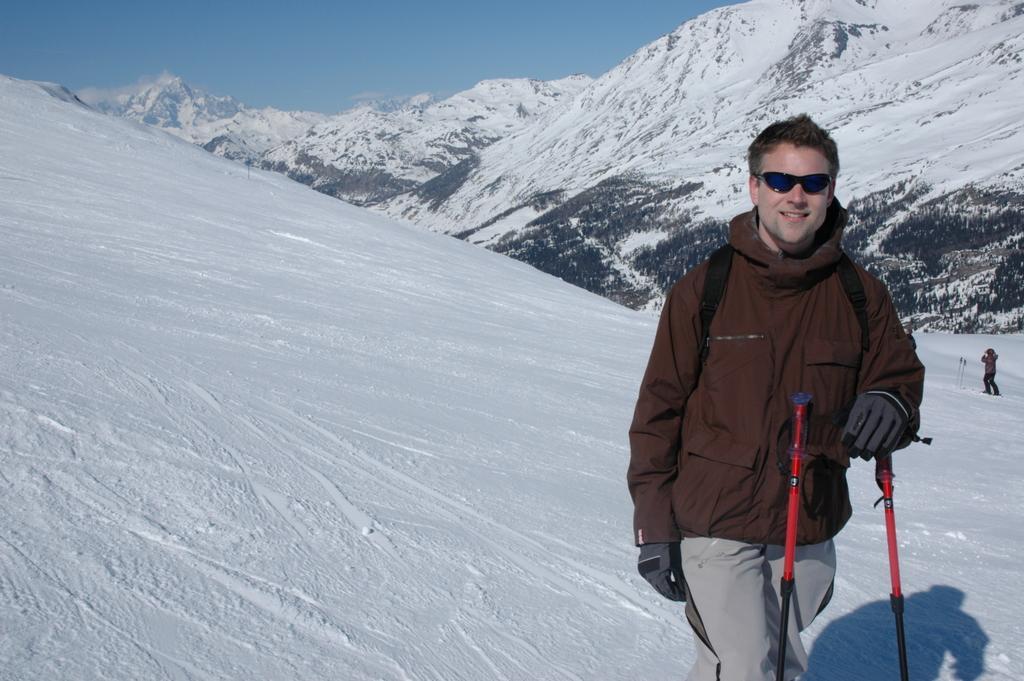Could you give a brief overview of what you see in this image? In this picture we can see a man standing and holding a ski pole. Behind the man, there are snowy mountains and a person. At the top of the image, there is the sky. 